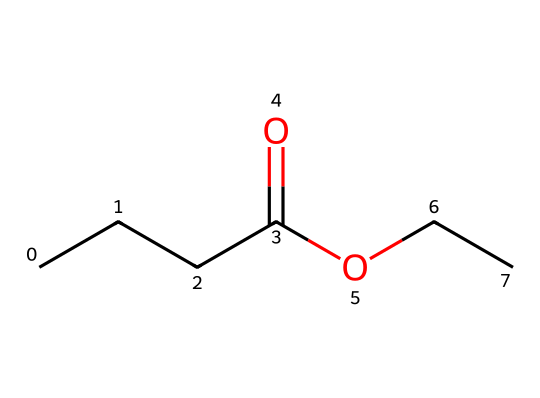What is the molecular formula of ethyl butyrate? The SMILES notation indicates the composition of the chemical is based on carbon (C), hydrogen (H), and oxygen (O) atoms. Counting the atoms gives C5, H10, and O2, resulting in the molecular formula C5H10O2.
Answer: C5H10O2 How many carbon atoms are in ethyl butyrate? By analyzing the SMILES representation, we identify five carbon atoms in the chain and functional groups present in the structure.
Answer: 5 What type of functional group is present in ethyl butyrate? The presence of the -O- and -C(=O)- indicates it contains an ester functional group. The -O- characterizes its ester nature, which arises from the bonding between an alcohol and a carboxylic acid.
Answer: ester What impact does ethyl butyrate have on aroma? Ethyl butyrate is known to impart fruity and tropical aromas, commonly associated with flavors of pineapple and mango, enhancing the sensory profile of beverages like beer.
Answer: fruity aroma How many hydrogen atoms are connected to the carbon atoms in ethyl butyrate? A careful analysis shows that each carbon atom in the structure contributes directly to the total number of hydrogen atoms, summing up to ten hydrogens based on the molecular formula derived from its structure.
Answer: 10 What characteristic does ethyl butyrate share with many flavor compounds? Ethyl butyrate, like many other flavor compounds, is a low molecular weight ester, which is a common trait that underlies its volatility and strong aroma profile, contributing to flavoring in beverages.
Answer: low molecular weight ester 